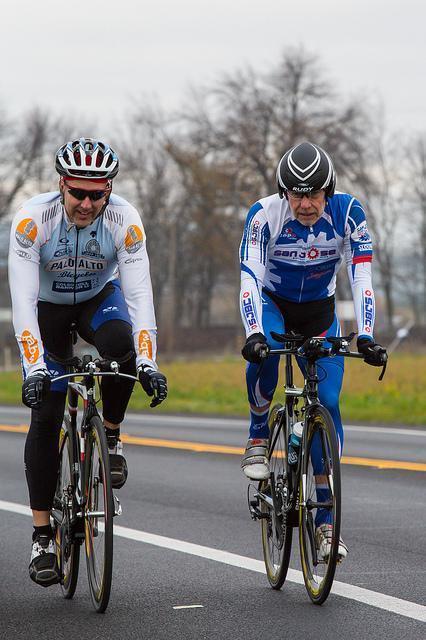How many men are there?
Give a very brief answer. 2. How many people are there?
Give a very brief answer. 2. How many bicycles can be seen?
Give a very brief answer. 2. How many horses are pictured?
Give a very brief answer. 0. 